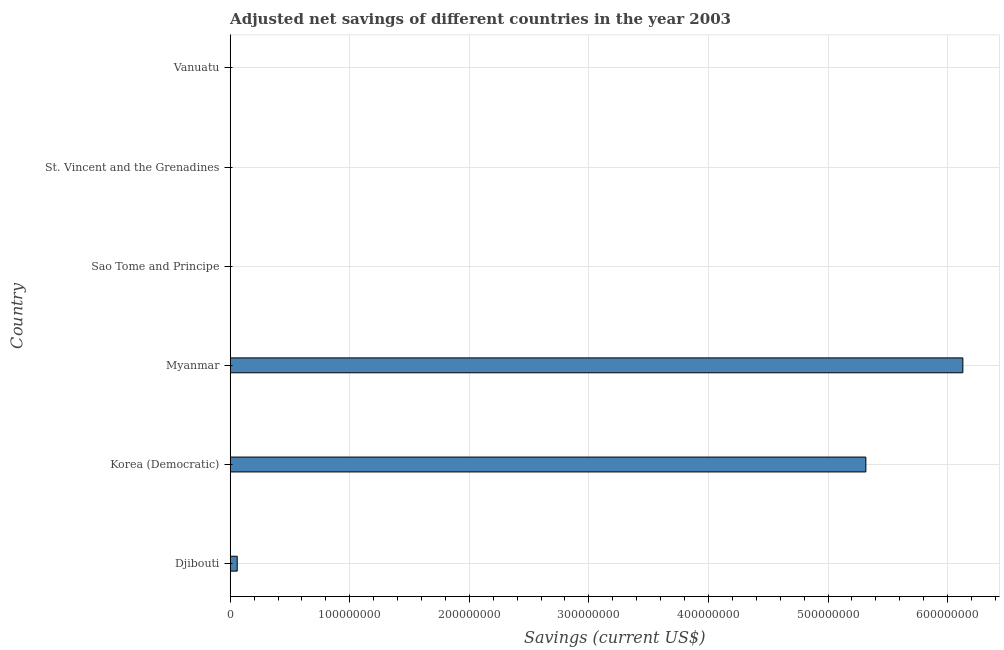Does the graph contain any zero values?
Provide a succinct answer. No. What is the title of the graph?
Provide a short and direct response. Adjusted net savings of different countries in the year 2003. What is the label or title of the X-axis?
Provide a short and direct response. Savings (current US$). What is the label or title of the Y-axis?
Ensure brevity in your answer.  Country. What is the adjusted net savings in Djibouti?
Your answer should be very brief. 5.88e+06. Across all countries, what is the maximum adjusted net savings?
Ensure brevity in your answer.  6.13e+08. Across all countries, what is the minimum adjusted net savings?
Your answer should be very brief. 1.27e+04. In which country was the adjusted net savings maximum?
Provide a succinct answer. Myanmar. In which country was the adjusted net savings minimum?
Keep it short and to the point. Sao Tome and Principe. What is the sum of the adjusted net savings?
Offer a very short reply. 1.15e+09. What is the difference between the adjusted net savings in Korea (Democratic) and Myanmar?
Offer a very short reply. -8.11e+07. What is the average adjusted net savings per country?
Give a very brief answer. 1.92e+08. What is the median adjusted net savings?
Provide a succinct answer. 3.06e+06. In how many countries, is the adjusted net savings greater than 100000000 US$?
Provide a succinct answer. 2. What is the ratio of the adjusted net savings in Korea (Democratic) to that in St. Vincent and the Grenadines?
Your answer should be compact. 4512.8. Is the adjusted net savings in Djibouti less than that in Vanuatu?
Keep it short and to the point. No. Is the difference between the adjusted net savings in Myanmar and Vanuatu greater than the difference between any two countries?
Keep it short and to the point. No. What is the difference between the highest and the second highest adjusted net savings?
Provide a succinct answer. 8.11e+07. What is the difference between the highest and the lowest adjusted net savings?
Provide a succinct answer. 6.13e+08. In how many countries, is the adjusted net savings greater than the average adjusted net savings taken over all countries?
Give a very brief answer. 2. How many countries are there in the graph?
Your response must be concise. 6. What is the difference between two consecutive major ticks on the X-axis?
Provide a short and direct response. 1.00e+08. What is the Savings (current US$) of Djibouti?
Give a very brief answer. 5.88e+06. What is the Savings (current US$) in Korea (Democratic)?
Keep it short and to the point. 5.32e+08. What is the Savings (current US$) in Myanmar?
Give a very brief answer. 6.13e+08. What is the Savings (current US$) of Sao Tome and Principe?
Give a very brief answer. 1.27e+04. What is the Savings (current US$) in St. Vincent and the Grenadines?
Provide a short and direct response. 1.18e+05. What is the Savings (current US$) of Vanuatu?
Your response must be concise. 2.46e+05. What is the difference between the Savings (current US$) in Djibouti and Korea (Democratic)?
Offer a terse response. -5.26e+08. What is the difference between the Savings (current US$) in Djibouti and Myanmar?
Your response must be concise. -6.07e+08. What is the difference between the Savings (current US$) in Djibouti and Sao Tome and Principe?
Your response must be concise. 5.87e+06. What is the difference between the Savings (current US$) in Djibouti and St. Vincent and the Grenadines?
Provide a succinct answer. 5.76e+06. What is the difference between the Savings (current US$) in Djibouti and Vanuatu?
Offer a terse response. 5.63e+06. What is the difference between the Savings (current US$) in Korea (Democratic) and Myanmar?
Keep it short and to the point. -8.11e+07. What is the difference between the Savings (current US$) in Korea (Democratic) and Sao Tome and Principe?
Offer a very short reply. 5.32e+08. What is the difference between the Savings (current US$) in Korea (Democratic) and St. Vincent and the Grenadines?
Ensure brevity in your answer.  5.32e+08. What is the difference between the Savings (current US$) in Korea (Democratic) and Vanuatu?
Give a very brief answer. 5.31e+08. What is the difference between the Savings (current US$) in Myanmar and Sao Tome and Principe?
Your answer should be compact. 6.13e+08. What is the difference between the Savings (current US$) in Myanmar and St. Vincent and the Grenadines?
Your response must be concise. 6.13e+08. What is the difference between the Savings (current US$) in Myanmar and Vanuatu?
Your response must be concise. 6.12e+08. What is the difference between the Savings (current US$) in Sao Tome and Principe and St. Vincent and the Grenadines?
Provide a succinct answer. -1.05e+05. What is the difference between the Savings (current US$) in Sao Tome and Principe and Vanuatu?
Offer a very short reply. -2.33e+05. What is the difference between the Savings (current US$) in St. Vincent and the Grenadines and Vanuatu?
Your answer should be very brief. -1.28e+05. What is the ratio of the Savings (current US$) in Djibouti to that in Korea (Democratic)?
Give a very brief answer. 0.01. What is the ratio of the Savings (current US$) in Djibouti to that in Myanmar?
Offer a very short reply. 0.01. What is the ratio of the Savings (current US$) in Djibouti to that in Sao Tome and Principe?
Make the answer very short. 462. What is the ratio of the Savings (current US$) in Djibouti to that in St. Vincent and the Grenadines?
Ensure brevity in your answer.  49.9. What is the ratio of the Savings (current US$) in Djibouti to that in Vanuatu?
Provide a short and direct response. 23.91. What is the ratio of the Savings (current US$) in Korea (Democratic) to that in Myanmar?
Provide a succinct answer. 0.87. What is the ratio of the Savings (current US$) in Korea (Democratic) to that in Sao Tome and Principe?
Ensure brevity in your answer.  4.18e+04. What is the ratio of the Savings (current US$) in Korea (Democratic) to that in St. Vincent and the Grenadines?
Your answer should be very brief. 4512.8. What is the ratio of the Savings (current US$) in Korea (Democratic) to that in Vanuatu?
Make the answer very short. 2162.07. What is the ratio of the Savings (current US$) in Myanmar to that in Sao Tome and Principe?
Make the answer very short. 4.82e+04. What is the ratio of the Savings (current US$) in Myanmar to that in St. Vincent and the Grenadines?
Provide a succinct answer. 5201.4. What is the ratio of the Savings (current US$) in Myanmar to that in Vanuatu?
Ensure brevity in your answer.  2491.98. What is the ratio of the Savings (current US$) in Sao Tome and Principe to that in St. Vincent and the Grenadines?
Provide a short and direct response. 0.11. What is the ratio of the Savings (current US$) in Sao Tome and Principe to that in Vanuatu?
Keep it short and to the point. 0.05. What is the ratio of the Savings (current US$) in St. Vincent and the Grenadines to that in Vanuatu?
Keep it short and to the point. 0.48. 